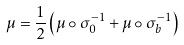<formula> <loc_0><loc_0><loc_500><loc_500>\mu = \frac { 1 } { 2 } \left ( \mu \circ \sigma _ { 0 } ^ { - 1 } + \mu \circ \sigma _ { b } ^ { - 1 } \right )</formula> 